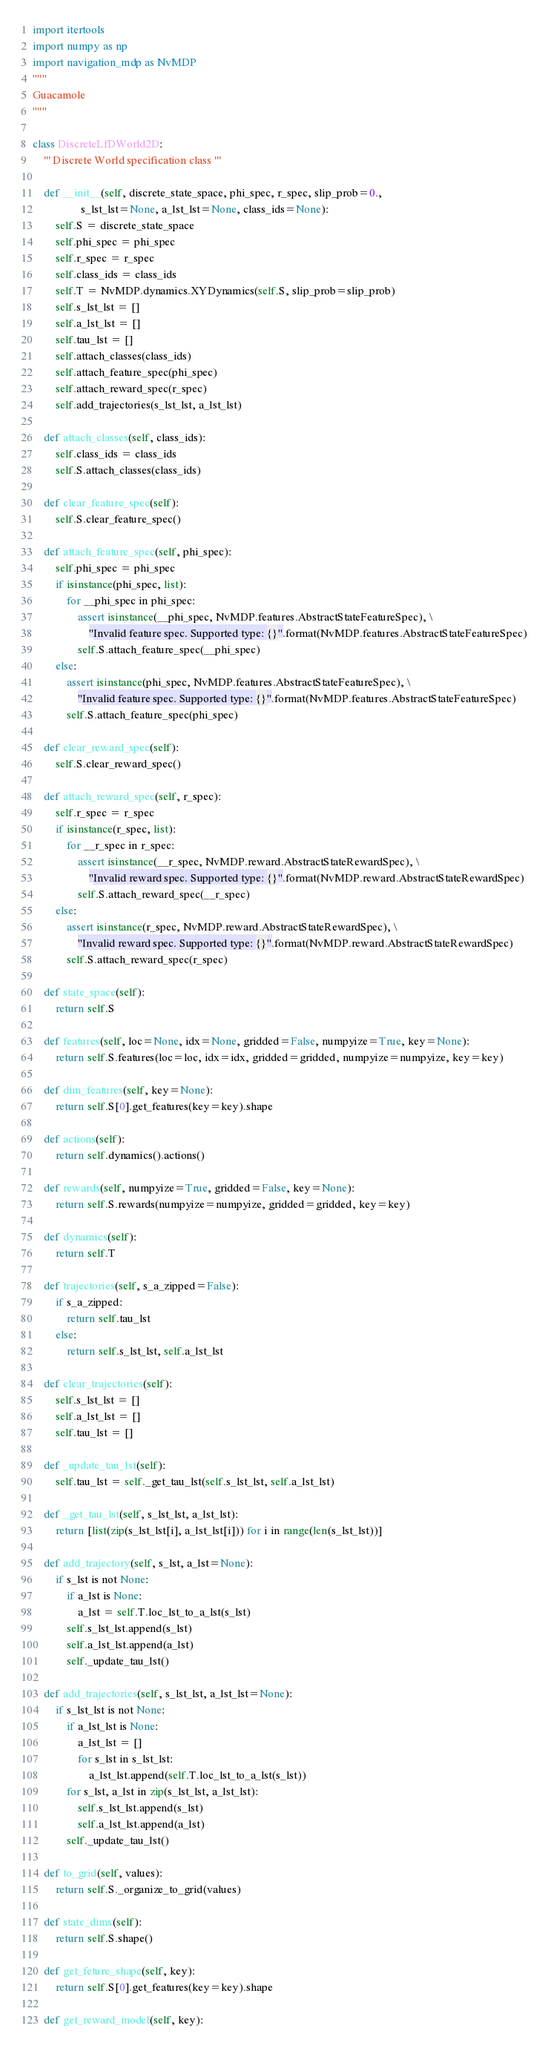Convert code to text. <code><loc_0><loc_0><loc_500><loc_500><_Python_>import itertools
import numpy as np
import navigation_mdp as NvMDP
"""
Guacamole
"""

class DiscreteLfDWorld2D:
    ''' Discrete World specification class '''

    def __init__(self, discrete_state_space, phi_spec, r_spec, slip_prob=0.,
                 s_lst_lst=None, a_lst_lst=None, class_ids=None):
        self.S = discrete_state_space
        self.phi_spec = phi_spec
        self.r_spec = r_spec
        self.class_ids = class_ids
        self.T = NvMDP.dynamics.XYDynamics(self.S, slip_prob=slip_prob)
        self.s_lst_lst = []
        self.a_lst_lst = []
        self.tau_lst = []
        self.attach_classes(class_ids)
        self.attach_feature_spec(phi_spec)
        self.attach_reward_spec(r_spec)
        self.add_trajectories(s_lst_lst, a_lst_lst)

    def attach_classes(self, class_ids):
        self.class_ids = class_ids
        self.S.attach_classes(class_ids)

    def clear_feature_spec(self):
        self.S.clear_feature_spec()

    def attach_feature_spec(self, phi_spec):
        self.phi_spec = phi_spec
        if isinstance(phi_spec, list):
            for __phi_spec in phi_spec:
                assert isinstance(__phi_spec, NvMDP.features.AbstractStateFeatureSpec), \
                    "Invalid feature spec. Supported type: {}".format(NvMDP.features.AbstractStateFeatureSpec)
                self.S.attach_feature_spec(__phi_spec)
        else:
            assert isinstance(phi_spec, NvMDP.features.AbstractStateFeatureSpec), \
                "Invalid feature spec. Supported type: {}".format(NvMDP.features.AbstractStateFeatureSpec)
            self.S.attach_feature_spec(phi_spec)

    def clear_reward_spec(self):
        self.S.clear_reward_spec()

    def attach_reward_spec(self, r_spec):
        self.r_spec = r_spec
        if isinstance(r_spec, list):
            for __r_spec in r_spec:
                assert isinstance(__r_spec, NvMDP.reward.AbstractStateRewardSpec), \
                    "Invalid reward spec. Supported type: {}".format(NvMDP.reward.AbstractStateRewardSpec)
                self.S.attach_reward_spec(__r_spec)
        else:
            assert isinstance(r_spec, NvMDP.reward.AbstractStateRewardSpec), \
                "Invalid reward spec. Supported type: {}".format(NvMDP.reward.AbstractStateRewardSpec)
            self.S.attach_reward_spec(r_spec)

    def state_space(self):
        return self.S

    def features(self, loc=None, idx=None, gridded=False, numpyize=True, key=None):
        return self.S.features(loc=loc, idx=idx, gridded=gridded, numpyize=numpyize, key=key)

    def dim_features(self, key=None):
        return self.S[0].get_features(key=key).shape

    def actions(self):
        return self.dynamics().actions()

    def rewards(self, numpyize=True, gridded=False, key=None):
        return self.S.rewards(numpyize=numpyize, gridded=gridded, key=key)

    def dynamics(self):
        return self.T

    def trajectories(self, s_a_zipped=False):
        if s_a_zipped:
            return self.tau_lst
        else:
            return self.s_lst_lst, self.a_lst_lst

    def clear_trajectories(self):
        self.s_lst_lst = []
        self.a_lst_lst = []
        self.tau_lst = []

    def _update_tau_lst(self):
        self.tau_lst = self._get_tau_lst(self.s_lst_lst, self.a_lst_lst)

    def _get_tau_lst(self, s_lst_lst, a_lst_lst):
        return [list(zip(s_lst_lst[i], a_lst_lst[i])) for i in range(len(s_lst_lst))]

    def add_trajectory(self, s_lst, a_lst=None):
        if s_lst is not None:
            if a_lst is None:
                a_lst = self.T.loc_lst_to_a_lst(s_lst)
            self.s_lst_lst.append(s_lst)
            self.a_lst_lst.append(a_lst)
            self._update_tau_lst()

    def add_trajectories(self, s_lst_lst, a_lst_lst=None):
        if s_lst_lst is not None:
            if a_lst_lst is None:
                a_lst_lst = []
                for s_lst in s_lst_lst:
                    a_lst_lst.append(self.T.loc_lst_to_a_lst(s_lst))
            for s_lst, a_lst in zip(s_lst_lst, a_lst_lst):
                self.s_lst_lst.append(s_lst)
                self.a_lst_lst.append(a_lst)
            self._update_tau_lst()

    def to_grid(self, values):
        return self.S._organize_to_grid(values)

    def state_dims(self):
        return self.S.shape()

    def get_feture_shape(self, key):
        return self.S[0].get_features(key=key).shape

    def get_reward_model(self, key):</code> 